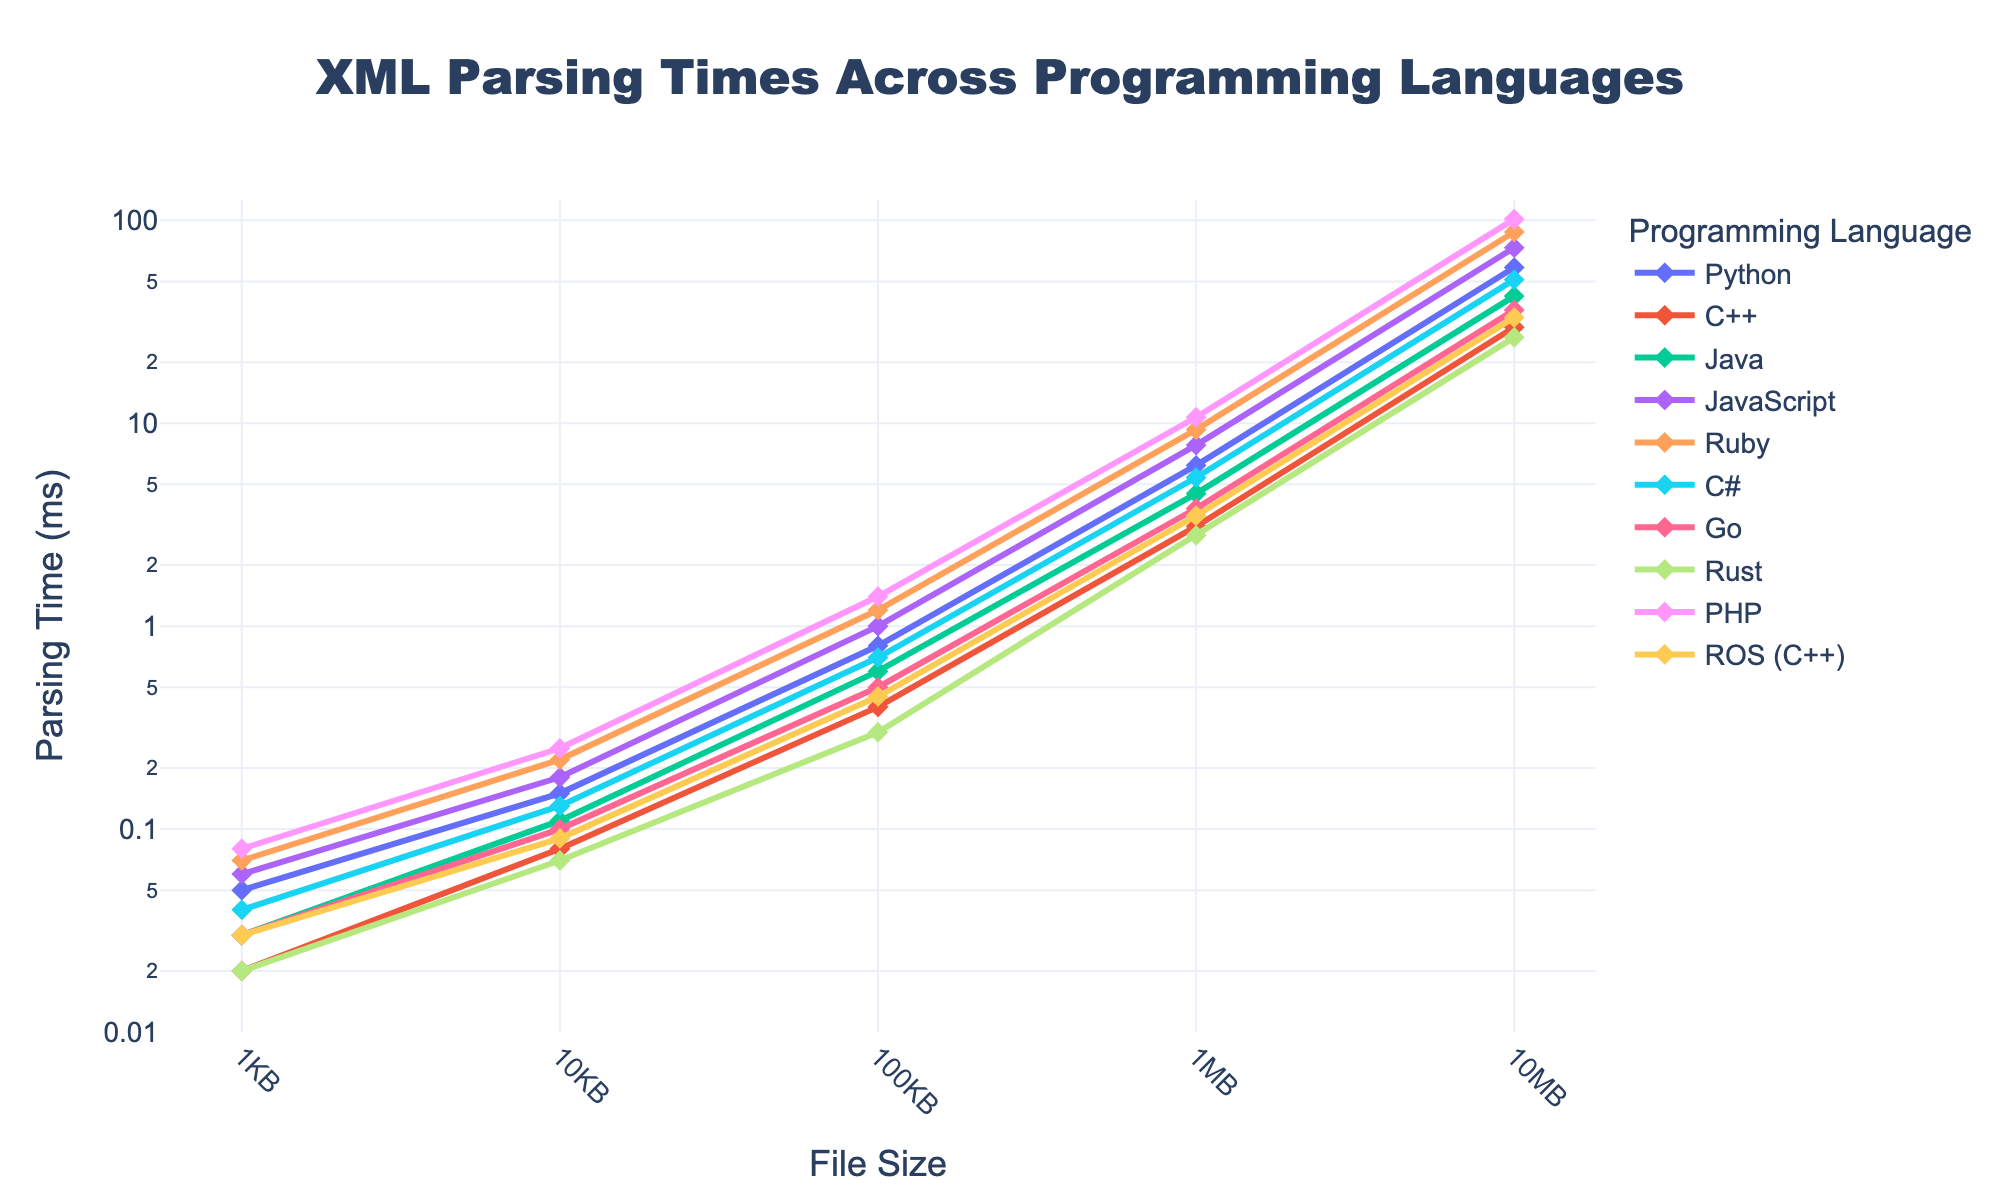Which programming language has the quickest parsing time for a 1MB file? On the chart, locate the point corresponding to a 1MB file for each programming language and compare their values. The lowest value indicates the quickest parsing time.
Answer: Rust How much slower is JavaScript compared to Rust for a 10MB file? On the chart, find the parsing time for a 10MB file for both JavaScript and Rust. Calculate the difference (JavaScript time - Rust time).
Answer: 46.7 ms What is the average parsing time across all programming languages for a 100KB file? Identify the parsing times for a 100KB file for all languages and calculate their average: (0.8+0.4+0.6+1.0+1.2+0.7+0.5+0.3+1.4+0.45)/10.
Answer: 0.735 ms Which programming language shows the most significant increase in parsing time as file size grows from 1KB to 10MB? Examine the line chart to identify the language with the steepest upward curve from 1KB to 10MB.
Answer: PHP Does C++ always parse files faster than Java? Compare the parsing times for C++ and Java at all file sizes (1KB, 10KB, 100KB, 1MB, 10MB) to see if C++ is always lower.
Answer: Yes Which programming languages have similar parsing times for 1KB files, and what are those times? On the chart, find and compare the points for 1KB files. Identify languages with similar values.
Answer: Python (0.05 ms) and C# (0.04 ms) For a file size of 1MB, rank the languages by their parsing times in ascending order. Identify and list the parsing times for a 1MB file for each language, then sort them from smallest to largest.
Answer: Rust, C++, ROS (C++), Go, Java, C#, Python, JavaScript, Ruby, PHP What is the parsing time difference between ROS (C++) and Go for a 10MB file? Find the parsing times for a 10MB file for both ROS (C++) and Go. Calculate the difference (ROS (C++) time - Go time).
Answer: -2.9 ms Which programming language has the highest parsing time for a 1KB file? On the chart, identify the point for a 1KB file for each programming language and determine which one has the highest value.
Answer: PHP 